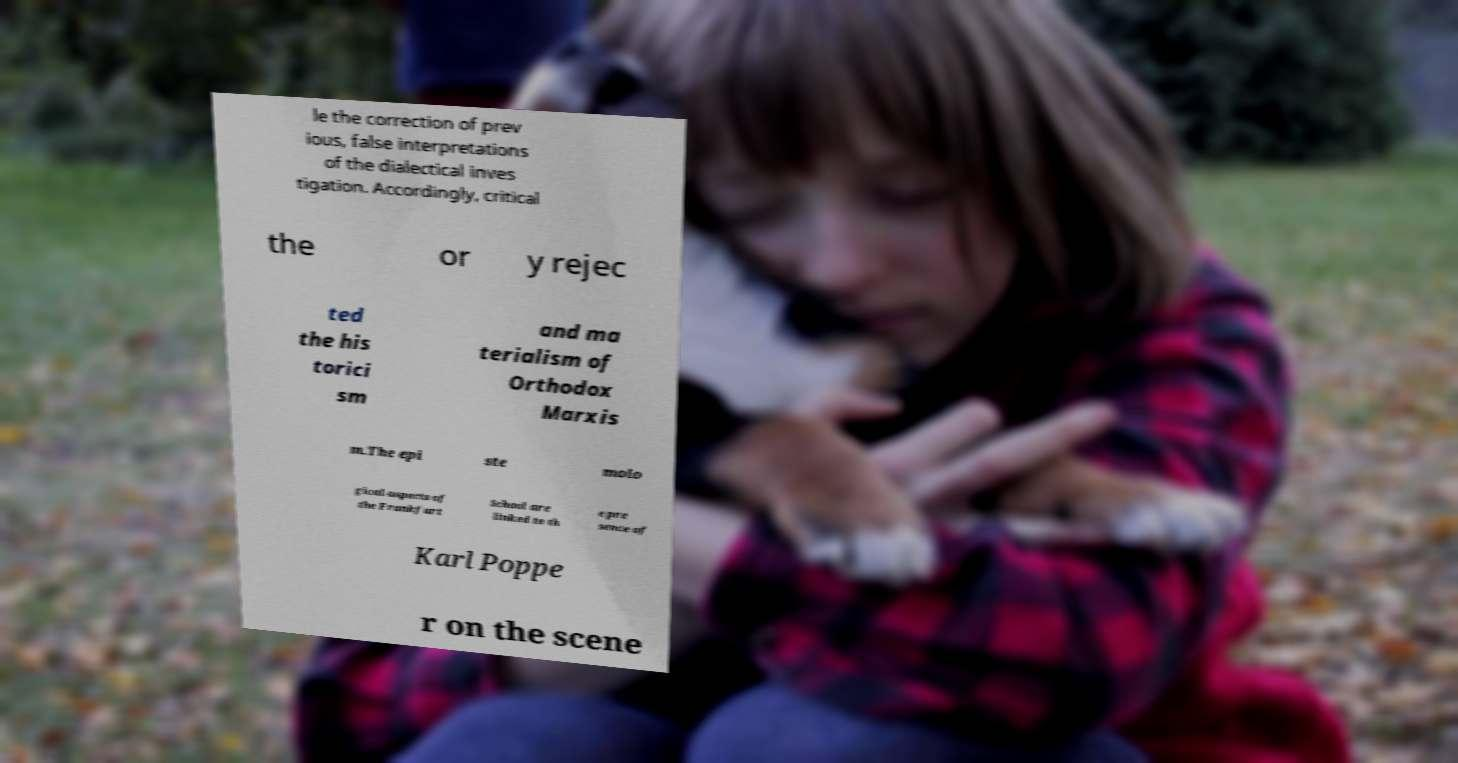Can you read and provide the text displayed in the image?This photo seems to have some interesting text. Can you extract and type it out for me? le the correction of prev ious, false interpretations of the dialectical inves tigation. Accordingly, critical the or y rejec ted the his torici sm and ma terialism of Orthodox Marxis m.The epi ste molo gical aspects of the Frankfurt School are linked to th e pre sence of Karl Poppe r on the scene 